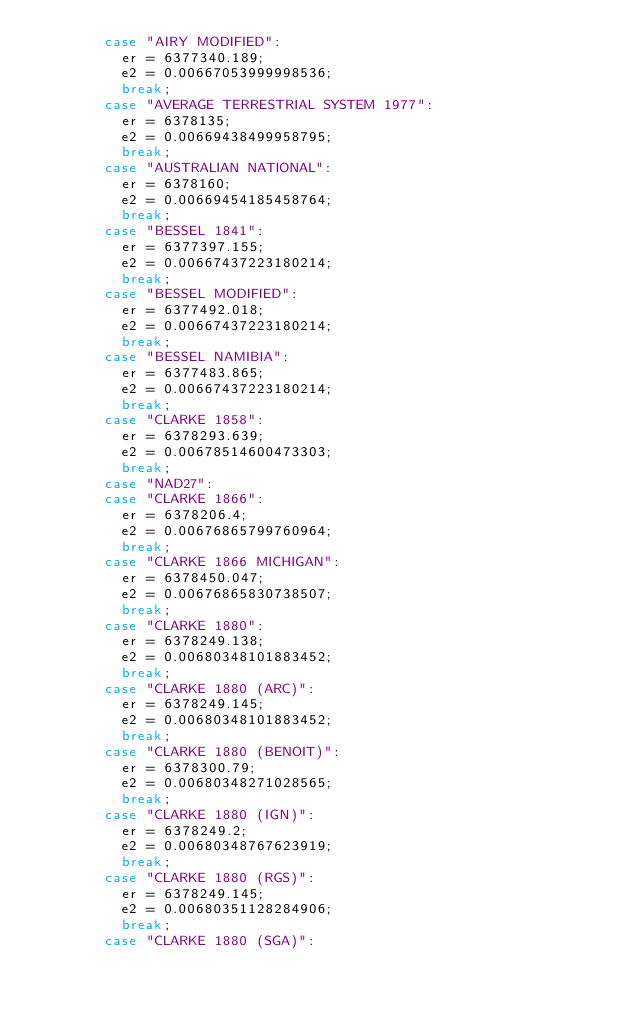<code> <loc_0><loc_0><loc_500><loc_500><_JavaScript_>        case "AIRY MODIFIED":
          er = 6377340.189;
          e2 = 0.00667053999998536;
          break;
        case "AVERAGE TERRESTRIAL SYSTEM 1977":
          er = 6378135;
          e2 = 0.00669438499958795;
          break;
        case "AUSTRALIAN NATIONAL":
          er = 6378160;
          e2 = 0.00669454185458764;
          break;
        case "BESSEL 1841":
          er = 6377397.155;
          e2 = 0.00667437223180214;
          break;
        case "BESSEL MODIFIED":
          er = 6377492.018;
          e2 = 0.00667437223180214;
          break;
        case "BESSEL NAMIBIA":
          er = 6377483.865;
          e2 = 0.00667437223180214;
          break;
        case "CLARKE 1858":
          er = 6378293.639;
          e2 = 0.00678514600473303;
          break;
        case "NAD27":
        case "CLARKE 1866":
          er = 6378206.4;
          e2 = 0.00676865799760964;
          break;
        case "CLARKE 1866 MICHIGAN":
          er = 6378450.047;
          e2 = 0.00676865830738507;
          break;
        case "CLARKE 1880":
          er = 6378249.138;
          e2 = 0.00680348101883452;
          break;
        case "CLARKE 1880 (ARC)":
          er = 6378249.145;
          e2 = 0.00680348101883452;
          break;
        case "CLARKE 1880 (BENOIT)":
          er = 6378300.79;
          e2 = 0.00680348271028565;
          break;
        case "CLARKE 1880 (IGN)":
          er = 6378249.2;
          e2 = 0.00680348767623919;
          break;
        case "CLARKE 1880 (RGS)":
          er = 6378249.145;
          e2 = 0.00680351128284906;
          break;
        case "CLARKE 1880 (SGA)":</code> 